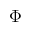Convert formula to latex. <formula><loc_0><loc_0><loc_500><loc_500>\Phi</formula> 